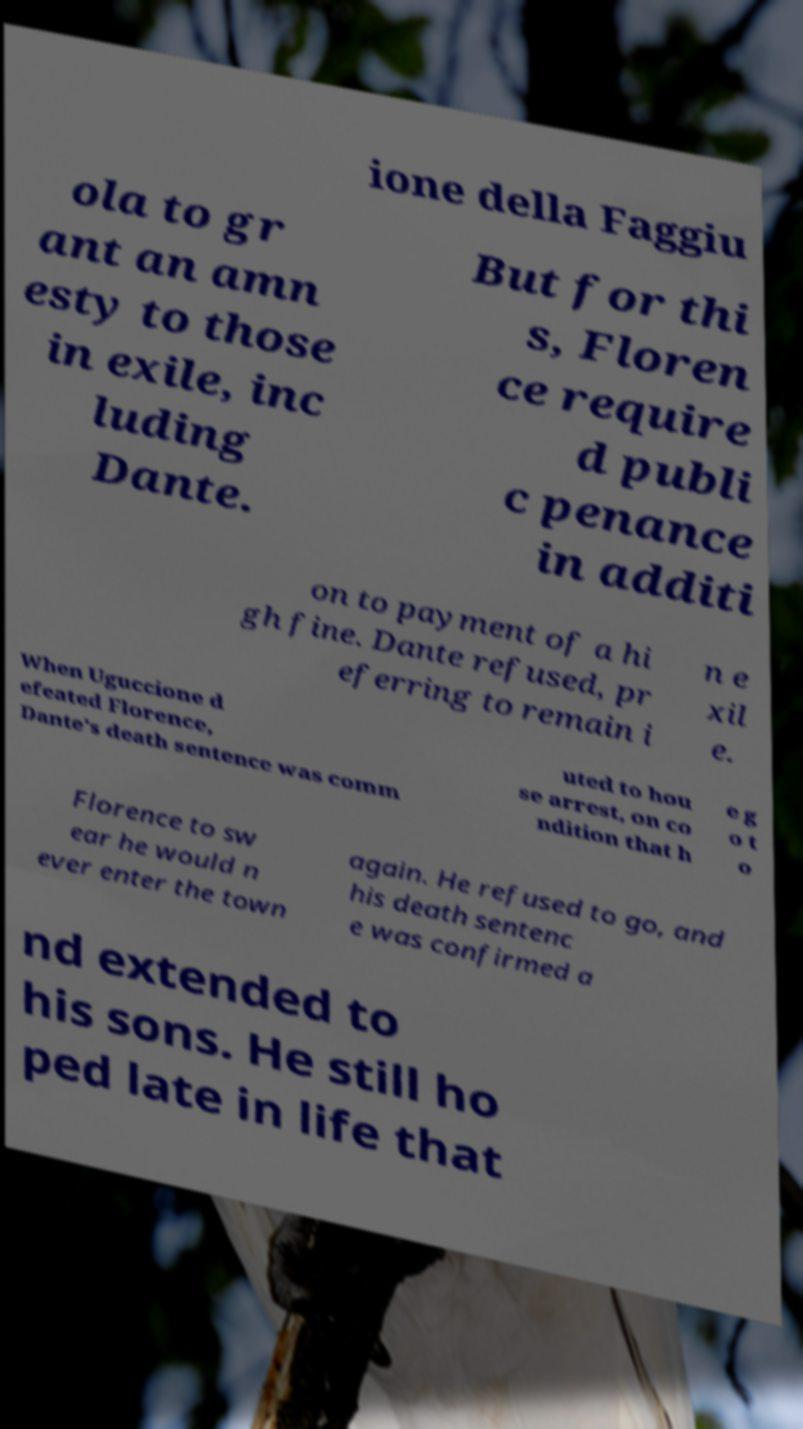Can you read and provide the text displayed in the image?This photo seems to have some interesting text. Can you extract and type it out for me? ione della Faggiu ola to gr ant an amn esty to those in exile, inc luding Dante. But for thi s, Floren ce require d publi c penance in additi on to payment of a hi gh fine. Dante refused, pr eferring to remain i n e xil e. When Uguccione d efeated Florence, Dante's death sentence was comm uted to hou se arrest, on co ndition that h e g o t o Florence to sw ear he would n ever enter the town again. He refused to go, and his death sentenc e was confirmed a nd extended to his sons. He still ho ped late in life that 